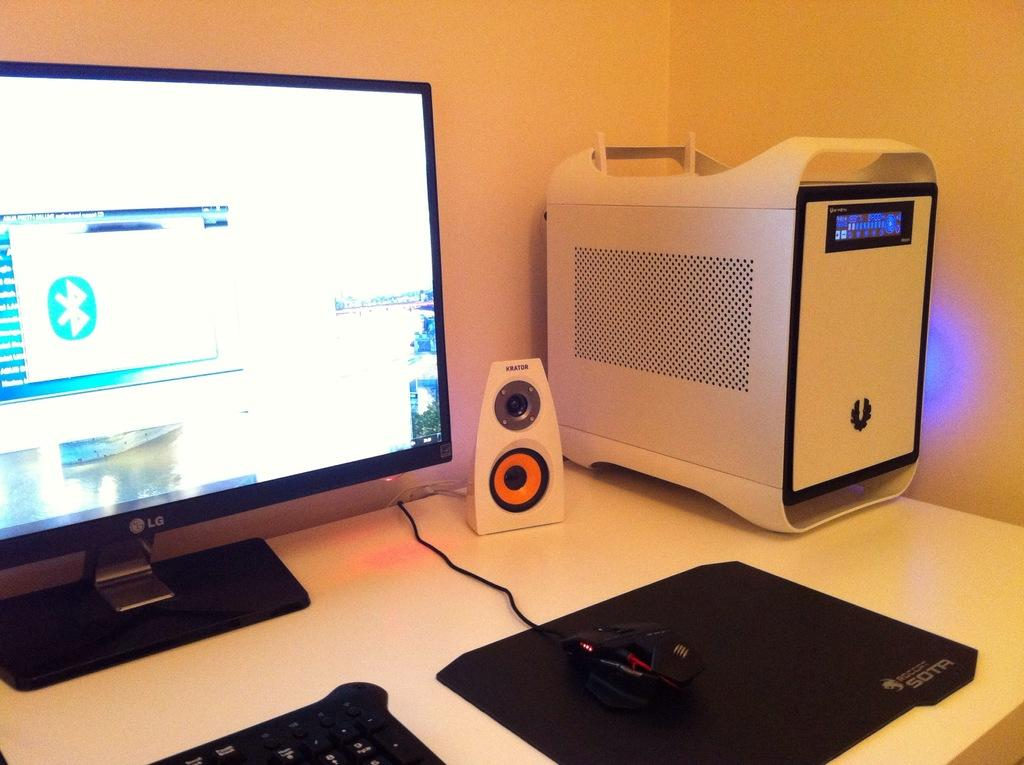<image>
Present a compact description of the photo's key features. Computer set up with a monitor from LG. 